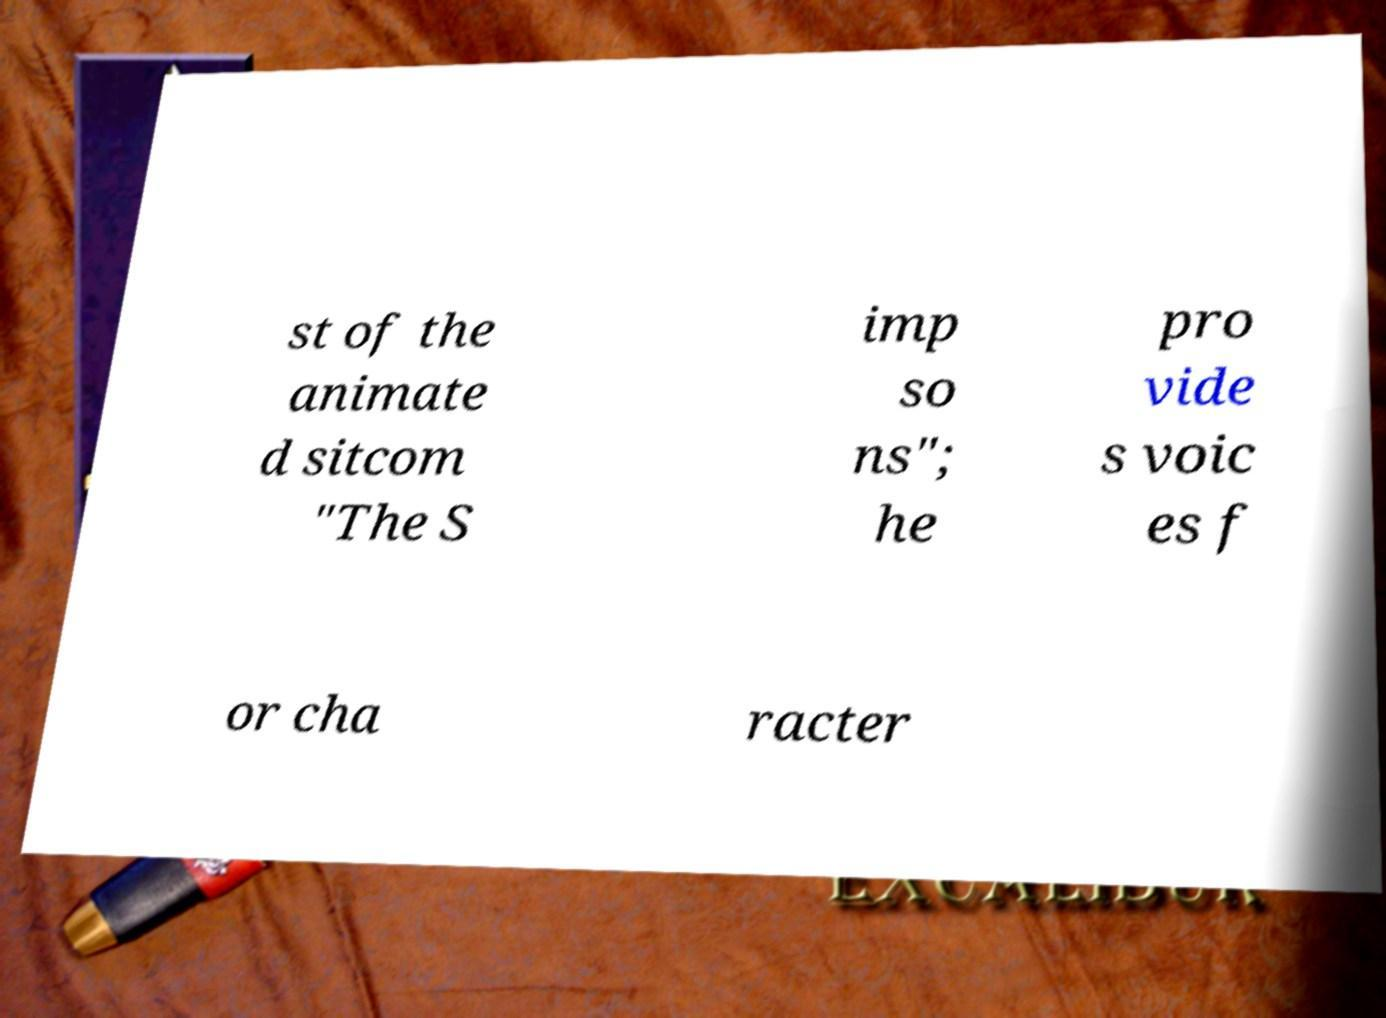What messages or text are displayed in this image? I need them in a readable, typed format. st of the animate d sitcom "The S imp so ns"; he pro vide s voic es f or cha racter 